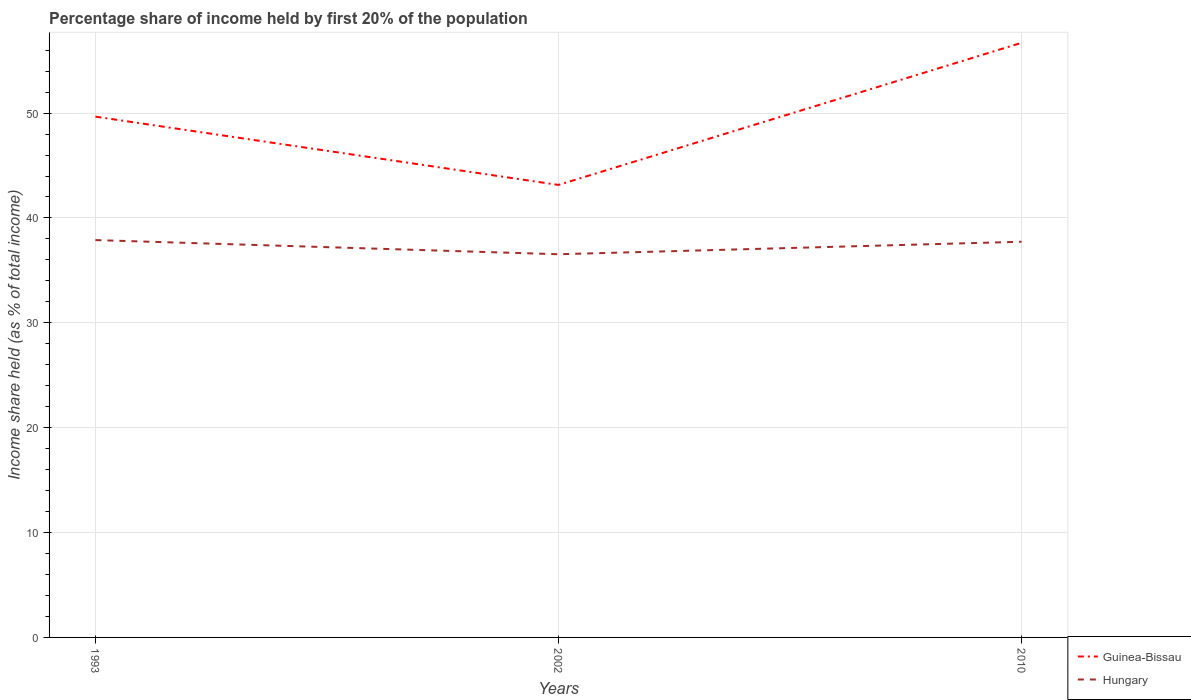Is the number of lines equal to the number of legend labels?
Keep it short and to the point. Yes. Across all years, what is the maximum share of income held by first 20% of the population in Guinea-Bissau?
Make the answer very short. 43.15. What is the total share of income held by first 20% of the population in Hungary in the graph?
Make the answer very short. -1.19. What is the difference between the highest and the second highest share of income held by first 20% of the population in Hungary?
Give a very brief answer. 1.35. What is the difference between the highest and the lowest share of income held by first 20% of the population in Hungary?
Offer a terse response. 2. Is the share of income held by first 20% of the population in Hungary strictly greater than the share of income held by first 20% of the population in Guinea-Bissau over the years?
Ensure brevity in your answer.  Yes. How many lines are there?
Provide a succinct answer. 2. What is the difference between two consecutive major ticks on the Y-axis?
Provide a short and direct response. 10. Are the values on the major ticks of Y-axis written in scientific E-notation?
Offer a terse response. No. Does the graph contain any zero values?
Provide a succinct answer. No. How many legend labels are there?
Keep it short and to the point. 2. How are the legend labels stacked?
Make the answer very short. Vertical. What is the title of the graph?
Your answer should be very brief. Percentage share of income held by first 20% of the population. What is the label or title of the X-axis?
Your answer should be compact. Years. What is the label or title of the Y-axis?
Ensure brevity in your answer.  Income share held (as % of total income). What is the Income share held (as % of total income) in Guinea-Bissau in 1993?
Your response must be concise. 49.66. What is the Income share held (as % of total income) in Hungary in 1993?
Make the answer very short. 37.89. What is the Income share held (as % of total income) in Guinea-Bissau in 2002?
Offer a terse response. 43.15. What is the Income share held (as % of total income) of Hungary in 2002?
Your answer should be very brief. 36.54. What is the Income share held (as % of total income) in Guinea-Bissau in 2010?
Ensure brevity in your answer.  56.7. What is the Income share held (as % of total income) in Hungary in 2010?
Keep it short and to the point. 37.73. Across all years, what is the maximum Income share held (as % of total income) in Guinea-Bissau?
Make the answer very short. 56.7. Across all years, what is the maximum Income share held (as % of total income) in Hungary?
Keep it short and to the point. 37.89. Across all years, what is the minimum Income share held (as % of total income) of Guinea-Bissau?
Ensure brevity in your answer.  43.15. Across all years, what is the minimum Income share held (as % of total income) of Hungary?
Make the answer very short. 36.54. What is the total Income share held (as % of total income) in Guinea-Bissau in the graph?
Offer a very short reply. 149.51. What is the total Income share held (as % of total income) of Hungary in the graph?
Offer a very short reply. 112.16. What is the difference between the Income share held (as % of total income) in Guinea-Bissau in 1993 and that in 2002?
Ensure brevity in your answer.  6.51. What is the difference between the Income share held (as % of total income) in Hungary in 1993 and that in 2002?
Provide a short and direct response. 1.35. What is the difference between the Income share held (as % of total income) of Guinea-Bissau in 1993 and that in 2010?
Offer a very short reply. -7.04. What is the difference between the Income share held (as % of total income) of Hungary in 1993 and that in 2010?
Provide a short and direct response. 0.16. What is the difference between the Income share held (as % of total income) of Guinea-Bissau in 2002 and that in 2010?
Provide a short and direct response. -13.55. What is the difference between the Income share held (as % of total income) of Hungary in 2002 and that in 2010?
Your answer should be very brief. -1.19. What is the difference between the Income share held (as % of total income) in Guinea-Bissau in 1993 and the Income share held (as % of total income) in Hungary in 2002?
Your answer should be compact. 13.12. What is the difference between the Income share held (as % of total income) in Guinea-Bissau in 1993 and the Income share held (as % of total income) in Hungary in 2010?
Keep it short and to the point. 11.93. What is the difference between the Income share held (as % of total income) in Guinea-Bissau in 2002 and the Income share held (as % of total income) in Hungary in 2010?
Your answer should be very brief. 5.42. What is the average Income share held (as % of total income) in Guinea-Bissau per year?
Keep it short and to the point. 49.84. What is the average Income share held (as % of total income) in Hungary per year?
Ensure brevity in your answer.  37.39. In the year 1993, what is the difference between the Income share held (as % of total income) in Guinea-Bissau and Income share held (as % of total income) in Hungary?
Your answer should be very brief. 11.77. In the year 2002, what is the difference between the Income share held (as % of total income) of Guinea-Bissau and Income share held (as % of total income) of Hungary?
Offer a very short reply. 6.61. In the year 2010, what is the difference between the Income share held (as % of total income) of Guinea-Bissau and Income share held (as % of total income) of Hungary?
Your response must be concise. 18.97. What is the ratio of the Income share held (as % of total income) of Guinea-Bissau in 1993 to that in 2002?
Offer a very short reply. 1.15. What is the ratio of the Income share held (as % of total income) of Hungary in 1993 to that in 2002?
Make the answer very short. 1.04. What is the ratio of the Income share held (as % of total income) in Guinea-Bissau in 1993 to that in 2010?
Provide a short and direct response. 0.88. What is the ratio of the Income share held (as % of total income) of Guinea-Bissau in 2002 to that in 2010?
Offer a very short reply. 0.76. What is the ratio of the Income share held (as % of total income) of Hungary in 2002 to that in 2010?
Give a very brief answer. 0.97. What is the difference between the highest and the second highest Income share held (as % of total income) of Guinea-Bissau?
Provide a succinct answer. 7.04. What is the difference between the highest and the second highest Income share held (as % of total income) of Hungary?
Ensure brevity in your answer.  0.16. What is the difference between the highest and the lowest Income share held (as % of total income) in Guinea-Bissau?
Keep it short and to the point. 13.55. What is the difference between the highest and the lowest Income share held (as % of total income) in Hungary?
Make the answer very short. 1.35. 